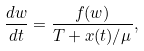Convert formula to latex. <formula><loc_0><loc_0><loc_500><loc_500>\frac { d w } { d t } = \frac { f ( w ) } { T + x ( t ) / \mu } ,</formula> 